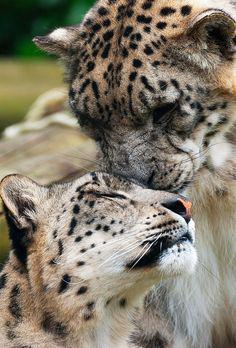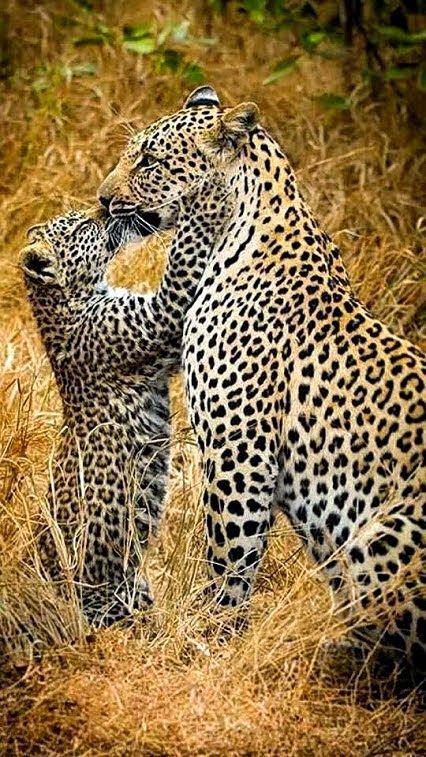The first image is the image on the left, the second image is the image on the right. Analyze the images presented: Is the assertion "The left image shows two spotted wildcats face to face, with heads level, and the right image shows exactly one spotted wildcat licking the other." valid? Answer yes or no. No. The first image is the image on the left, the second image is the image on the right. For the images displayed, is the sentence "At least one leopard's tongue is visible." factually correct? Answer yes or no. No. 